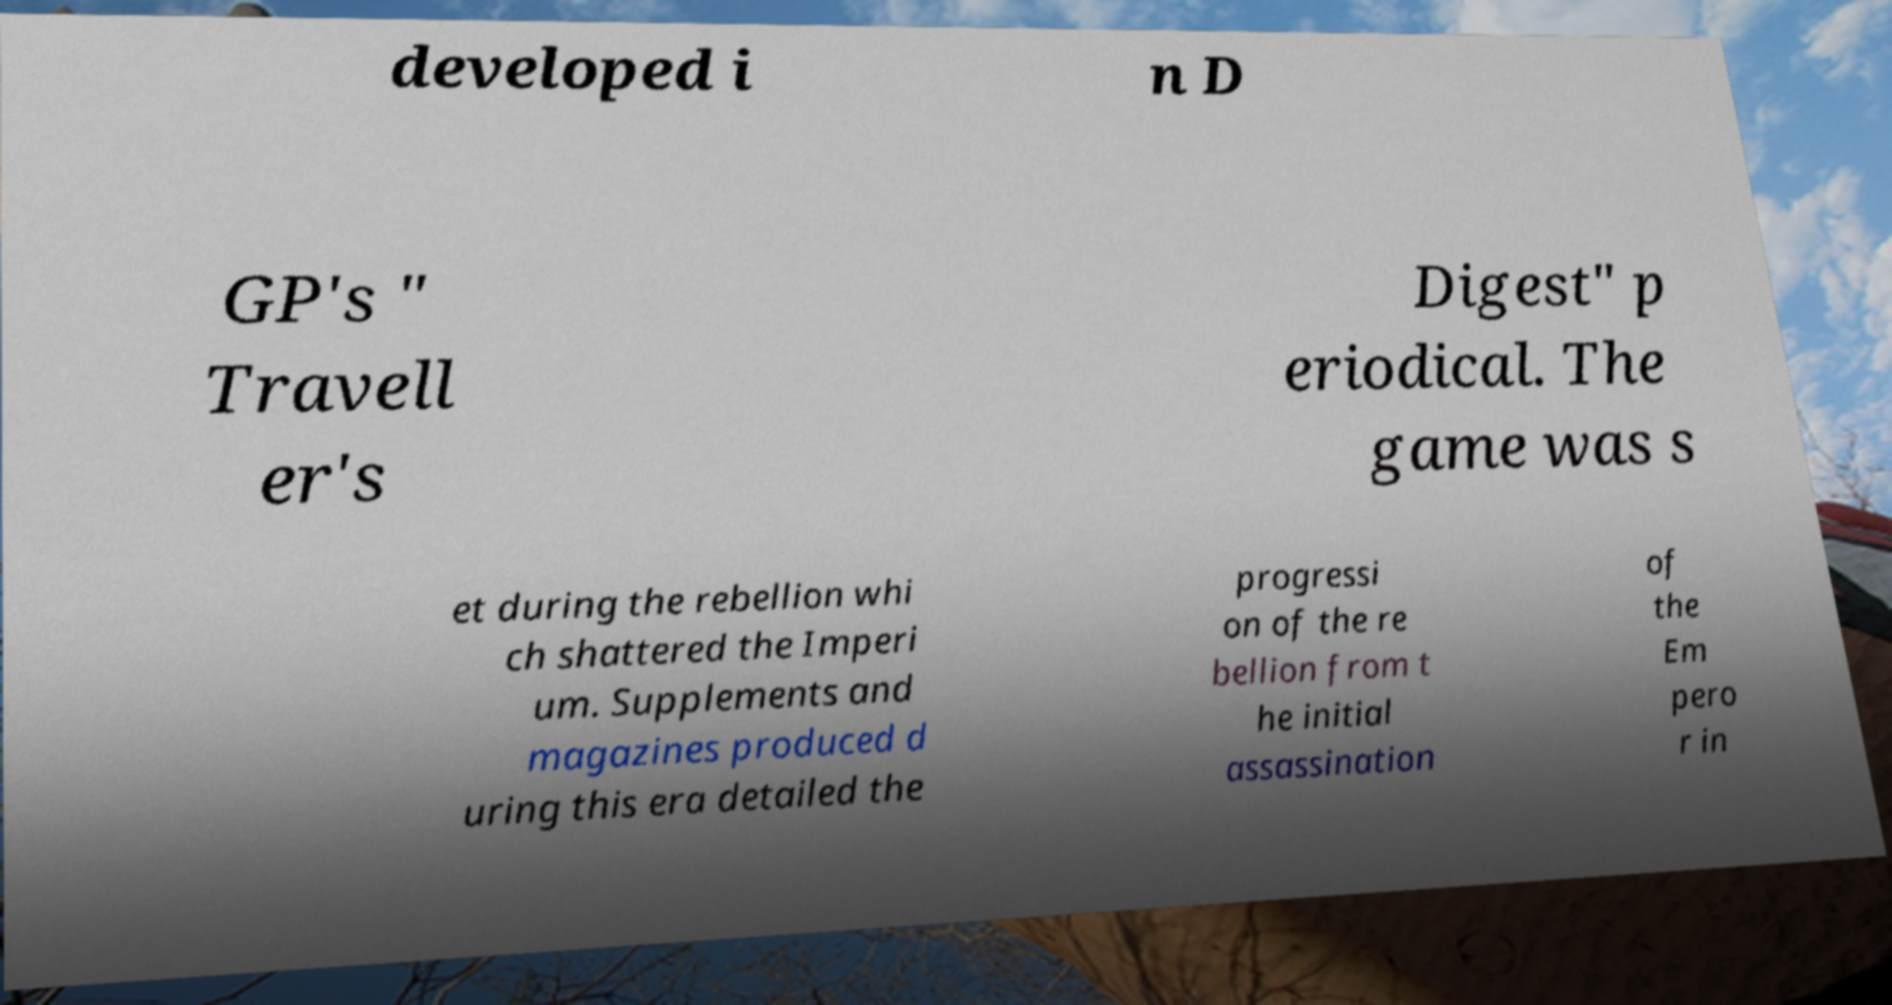Could you extract and type out the text from this image? developed i n D GP's " Travell er's Digest" p eriodical. The game was s et during the rebellion whi ch shattered the Imperi um. Supplements and magazines produced d uring this era detailed the progressi on of the re bellion from t he initial assassination of the Em pero r in 